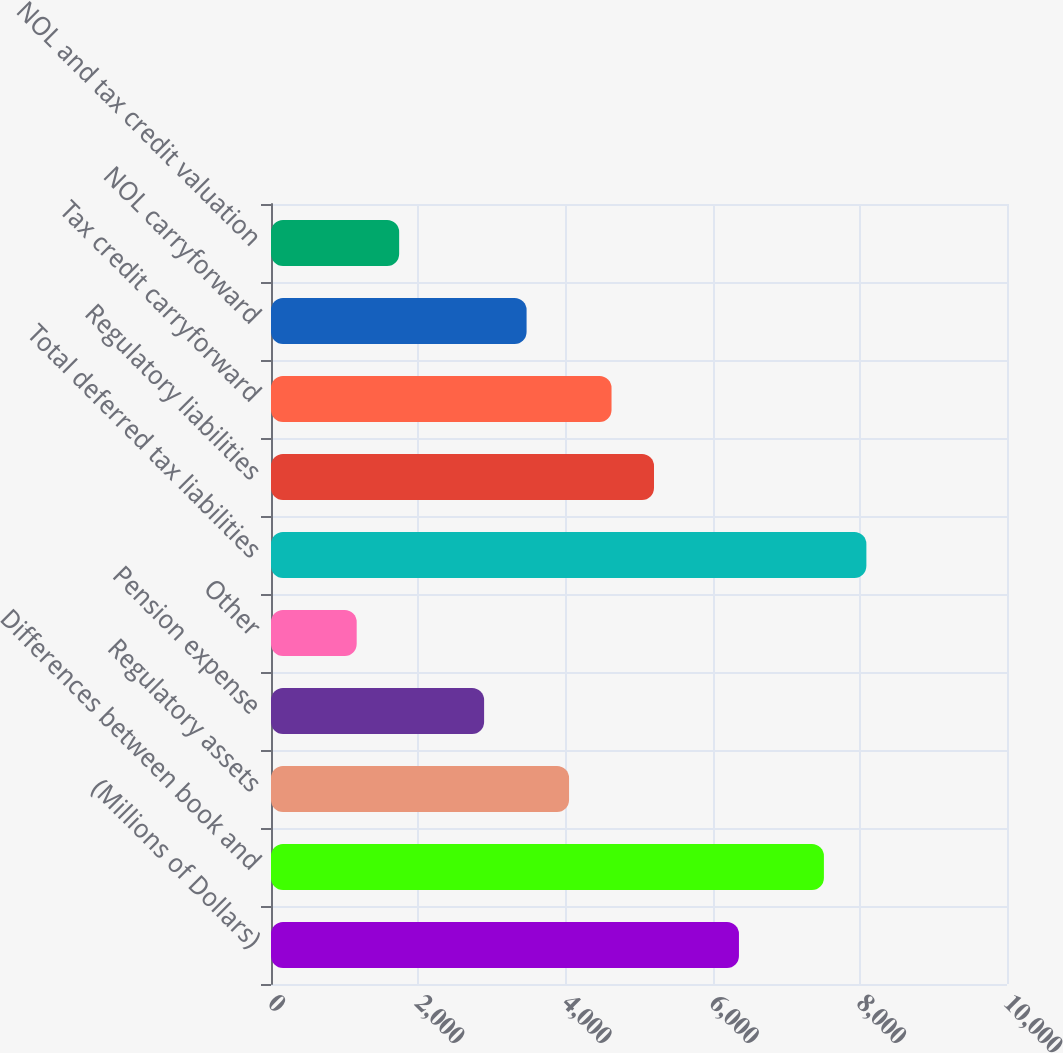<chart> <loc_0><loc_0><loc_500><loc_500><bar_chart><fcel>(Millions of Dollars)<fcel>Differences between book and<fcel>Regulatory assets<fcel>Pension expense<fcel>Other<fcel>Total deferred tax liabilities<fcel>Regulatory liabilities<fcel>Tax credit carryforward<fcel>NOL carryforward<fcel>NOL and tax credit valuation<nl><fcel>6358.1<fcel>7512.3<fcel>4049.7<fcel>2895.5<fcel>1164.2<fcel>8089.4<fcel>5203.9<fcel>4626.8<fcel>3472.6<fcel>1741.3<nl></chart> 